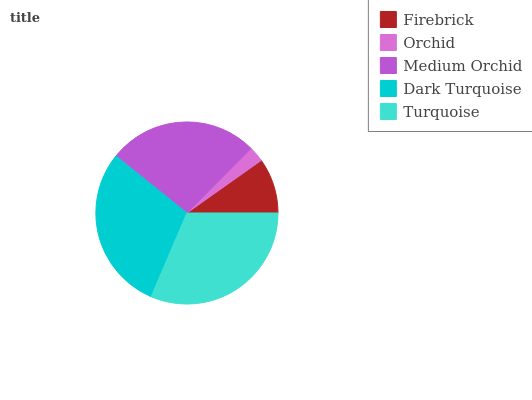Is Orchid the minimum?
Answer yes or no. Yes. Is Turquoise the maximum?
Answer yes or no. Yes. Is Medium Orchid the minimum?
Answer yes or no. No. Is Medium Orchid the maximum?
Answer yes or no. No. Is Medium Orchid greater than Orchid?
Answer yes or no. Yes. Is Orchid less than Medium Orchid?
Answer yes or no. Yes. Is Orchid greater than Medium Orchid?
Answer yes or no. No. Is Medium Orchid less than Orchid?
Answer yes or no. No. Is Medium Orchid the high median?
Answer yes or no. Yes. Is Medium Orchid the low median?
Answer yes or no. Yes. Is Dark Turquoise the high median?
Answer yes or no. No. Is Dark Turquoise the low median?
Answer yes or no. No. 